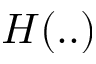Convert formula to latex. <formula><loc_0><loc_0><loc_500><loc_500>H ( . . )</formula> 